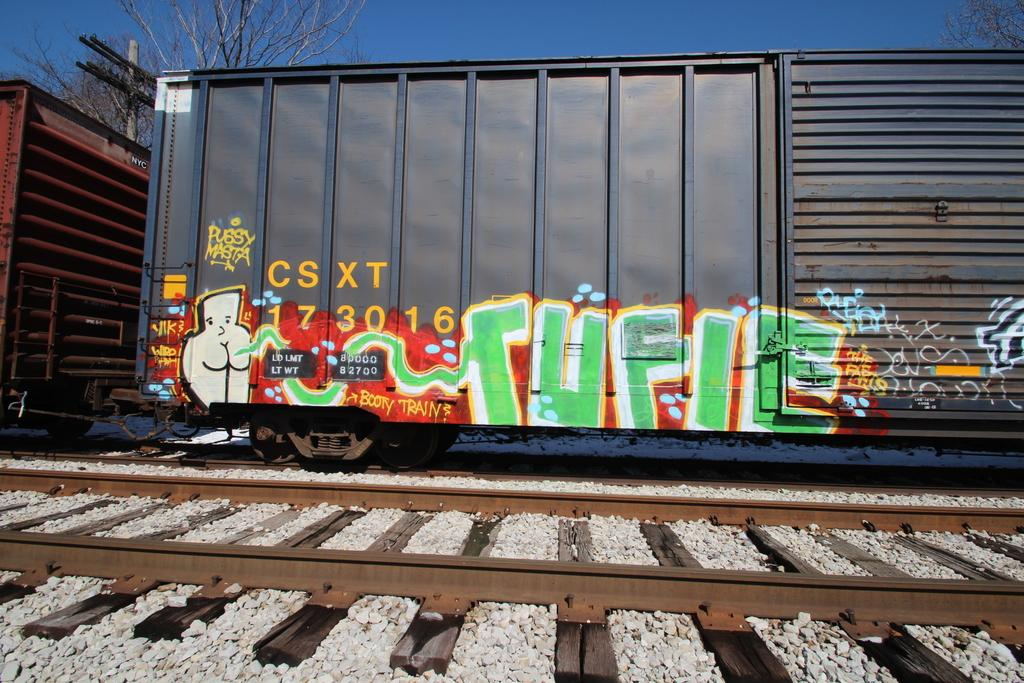Provide a one-sentence caption for the provided image. Train that says CSXT 173016 with some graffiti on it. 